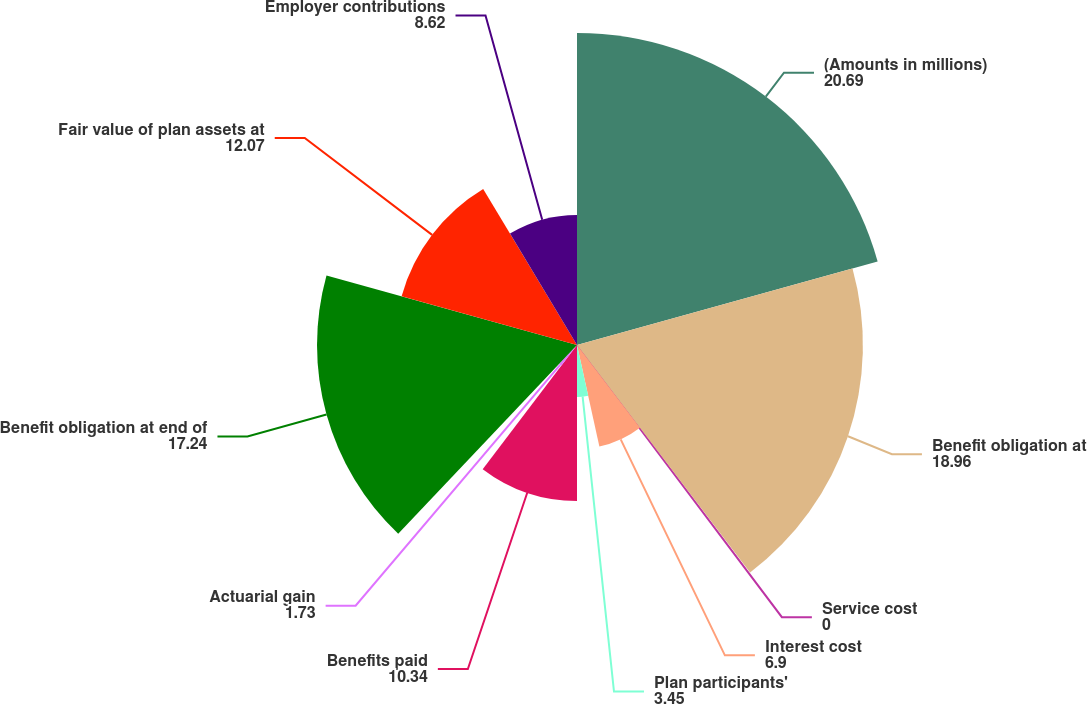Convert chart to OTSL. <chart><loc_0><loc_0><loc_500><loc_500><pie_chart><fcel>(Amounts in millions)<fcel>Benefit obligation at<fcel>Service cost<fcel>Interest cost<fcel>Plan participants'<fcel>Benefits paid<fcel>Actuarial gain<fcel>Benefit obligation at end of<fcel>Fair value of plan assets at<fcel>Employer contributions<nl><fcel>20.69%<fcel>18.96%<fcel>0.0%<fcel>6.9%<fcel>3.45%<fcel>10.34%<fcel>1.73%<fcel>17.24%<fcel>12.07%<fcel>8.62%<nl></chart> 